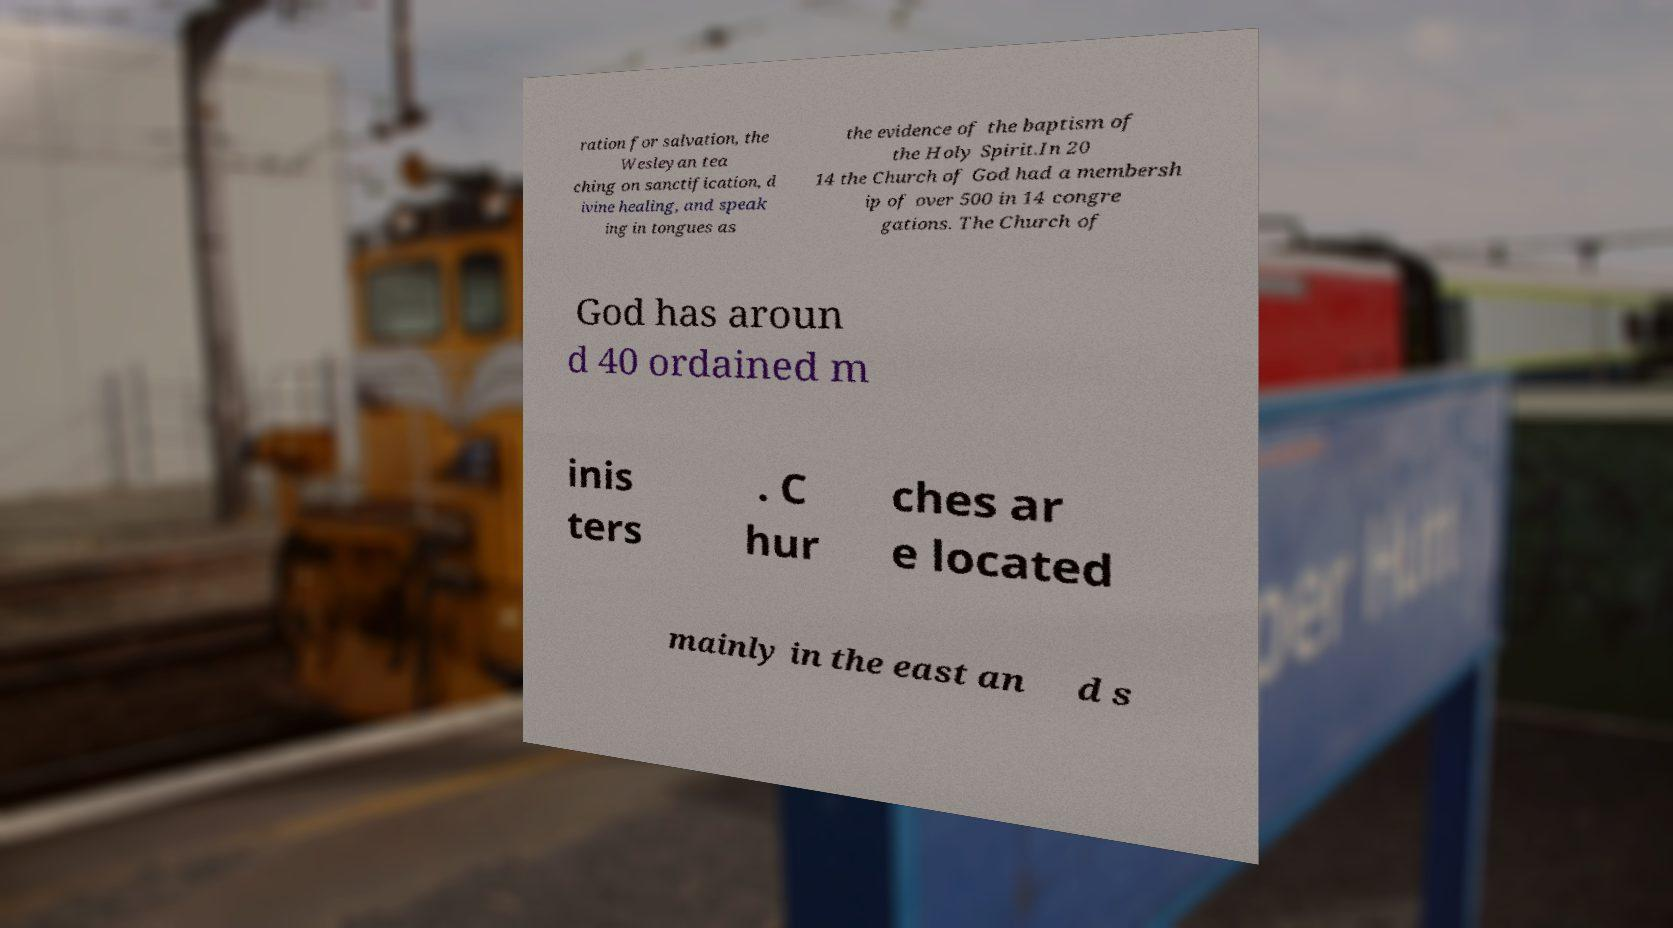Please read and relay the text visible in this image. What does it say? ration for salvation, the Wesleyan tea ching on sanctification, d ivine healing, and speak ing in tongues as the evidence of the baptism of the Holy Spirit.In 20 14 the Church of God had a membersh ip of over 500 in 14 congre gations. The Church of God has aroun d 40 ordained m inis ters . C hur ches ar e located mainly in the east an d s 